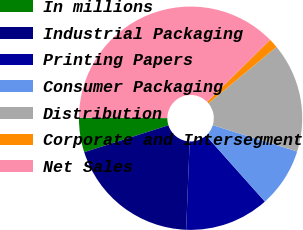Convert chart to OTSL. <chart><loc_0><loc_0><loc_500><loc_500><pie_chart><fcel>In millions<fcel>Industrial Packaging<fcel>Printing Papers<fcel>Consumer Packaging<fcel>Distribution<fcel>Corporate and Intersegment<fcel>Net Sales<nl><fcel>4.99%<fcel>19.45%<fcel>12.22%<fcel>8.6%<fcel>15.84%<fcel>1.37%<fcel>37.53%<nl></chart> 